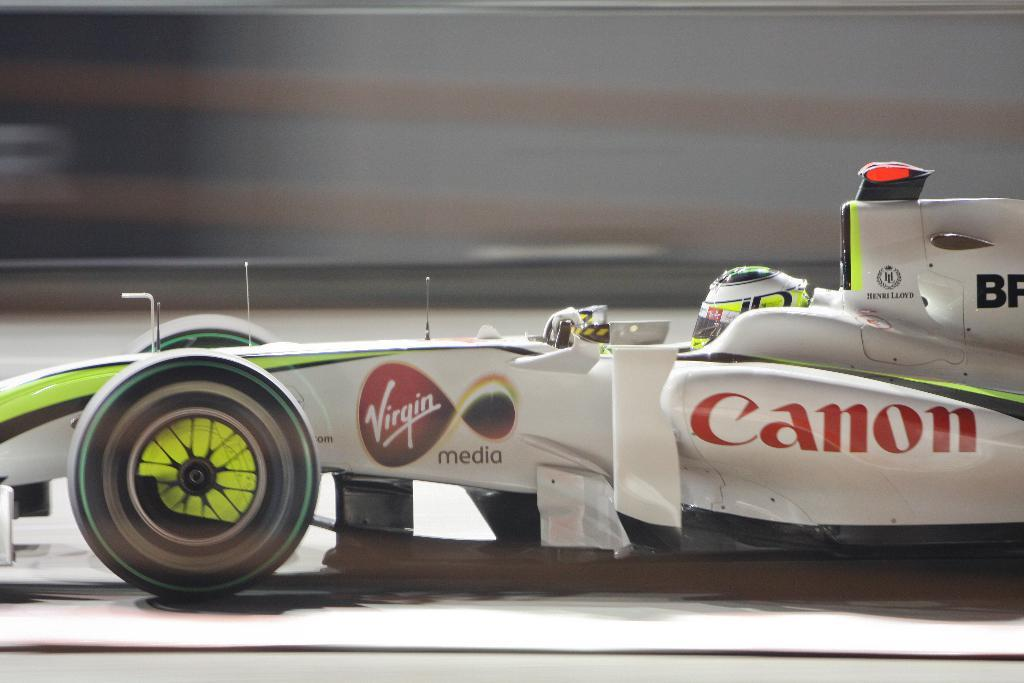What is the color of the vehicle in the image? The vehicle in the image is white. What can be seen inside the vehicle? A person is sitting in the vehicle. What type of dress is the manager wearing in the image? There is no manager or dress present in the image; it only features a white color vehicle with a person sitting inside. 